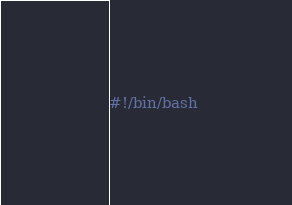<code> <loc_0><loc_0><loc_500><loc_500><_Bash_>#!/bin/bash
</code> 